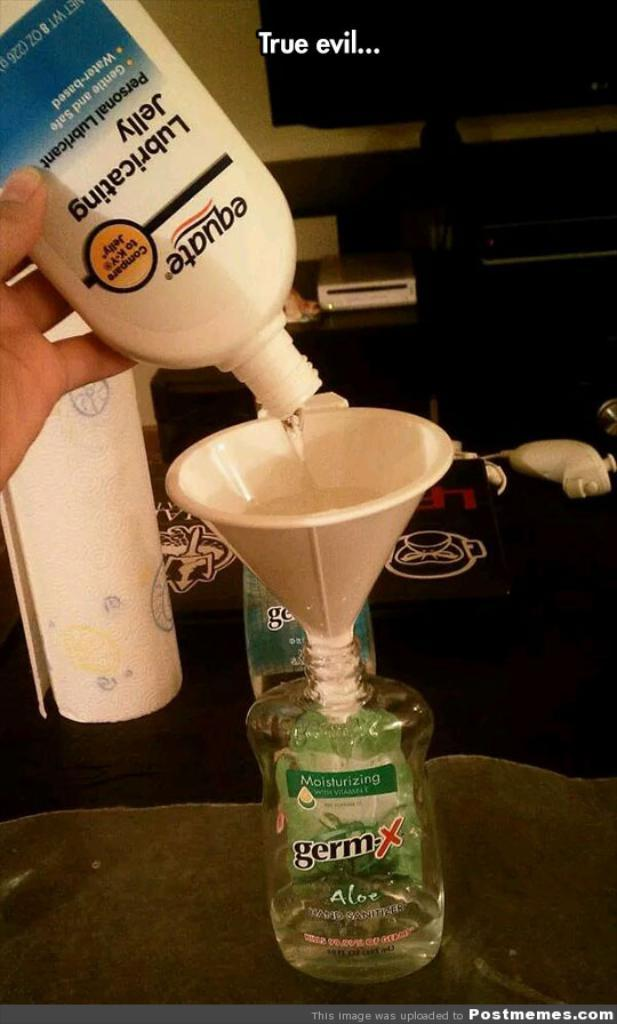<image>
Give a short and clear explanation of the subsequent image. someone pouring Lubricating Jelly into a bottle of Germ X with a funnel 